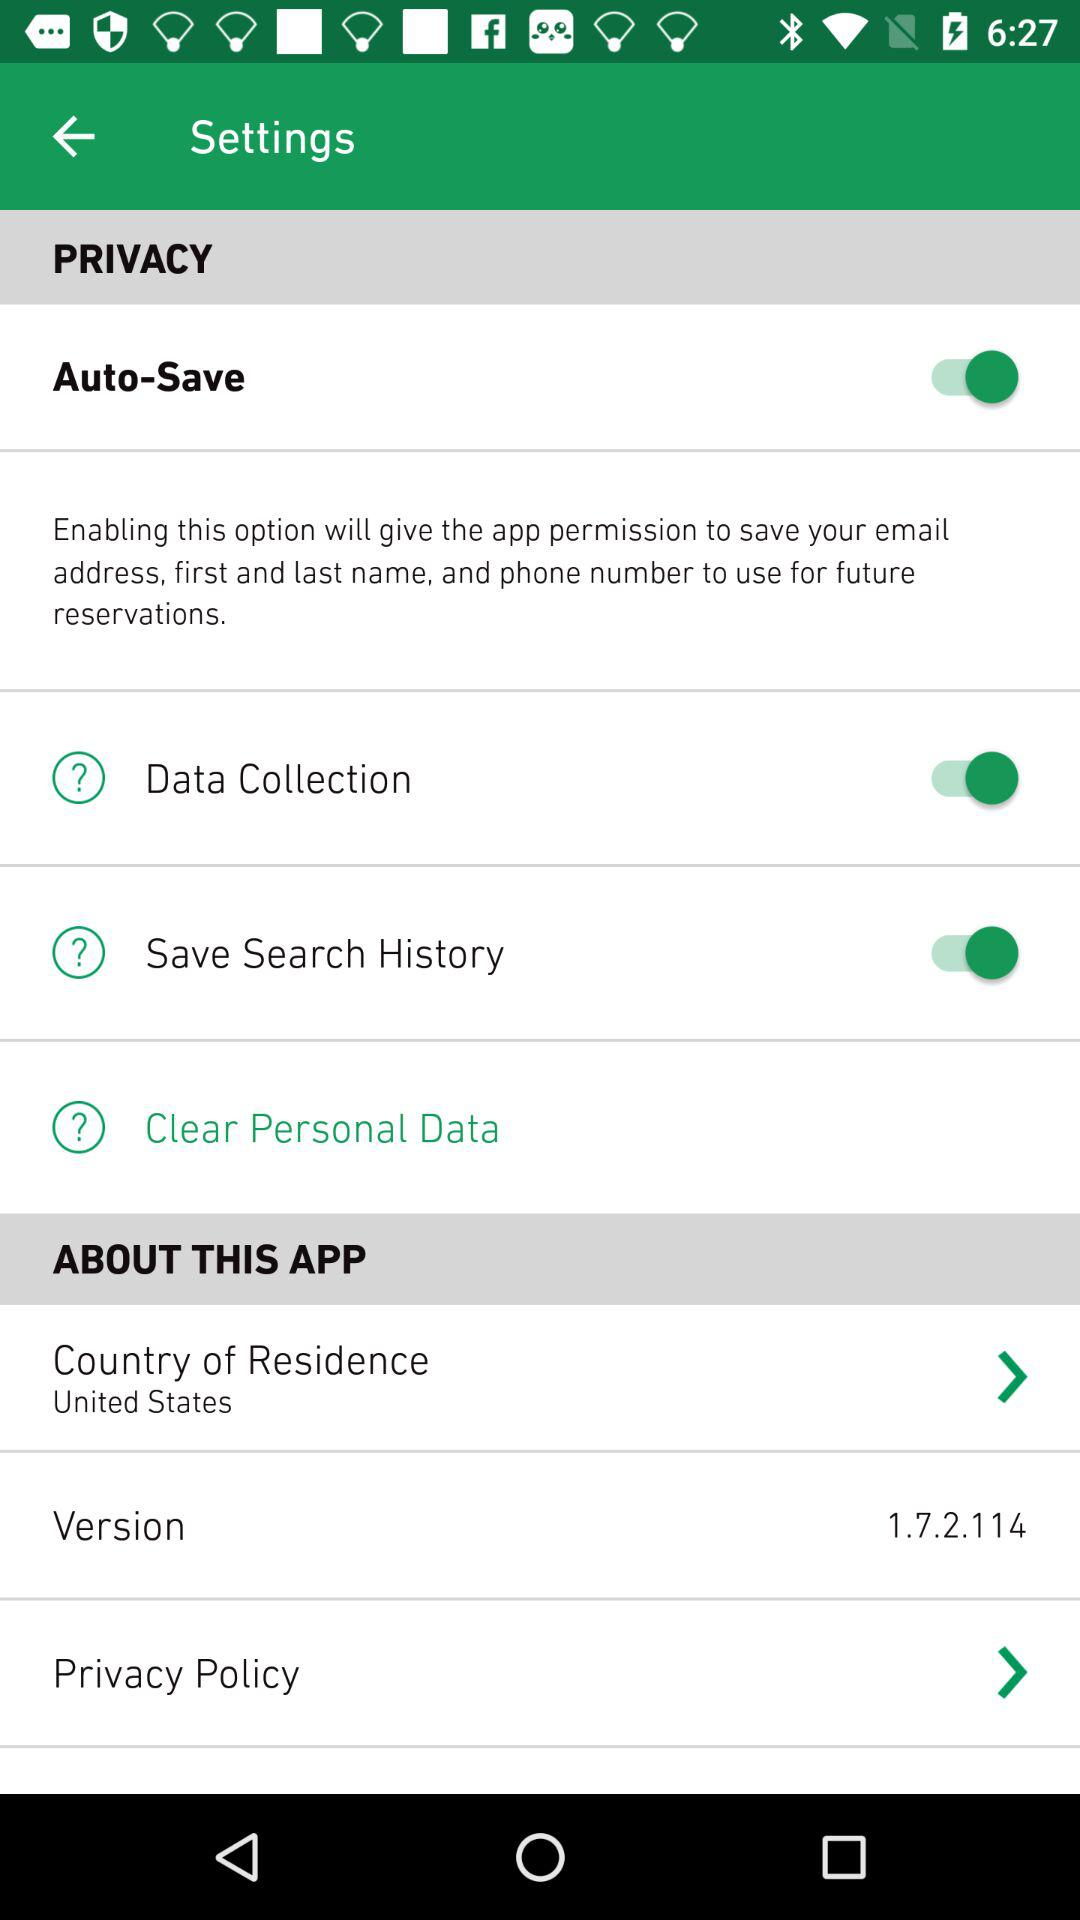What is the version of the app? The version is 1.7.2.114. 